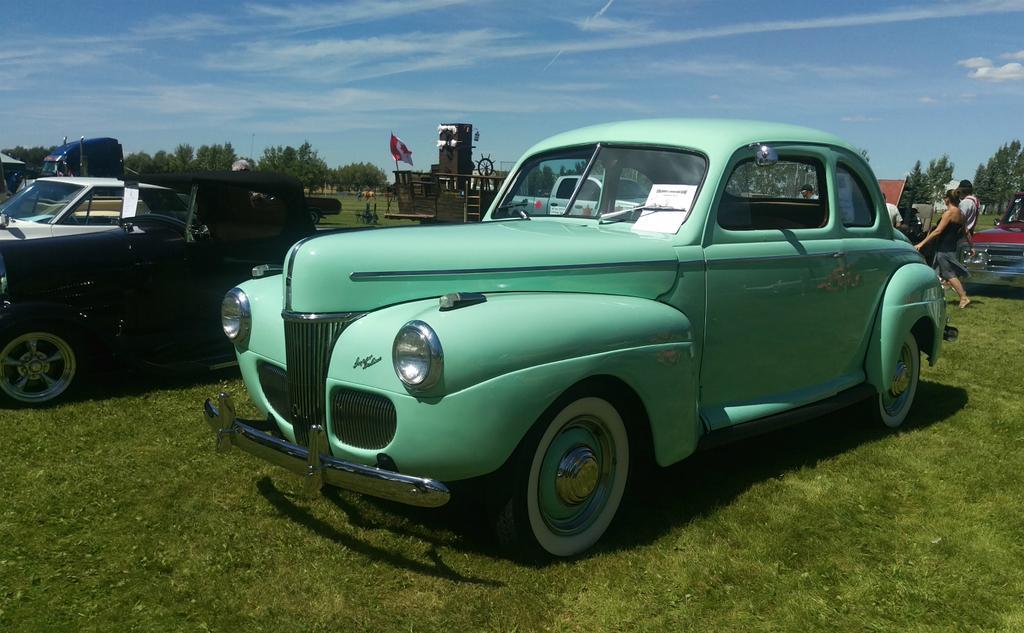Could you give a brief overview of what you see in this image? In this picture we can see some vehicles parked on the grass. Behind the vehicles there are a group of people. Behind the people, those are looking like houses, trees and the sky. On a vehicle, it looks like a flag. 